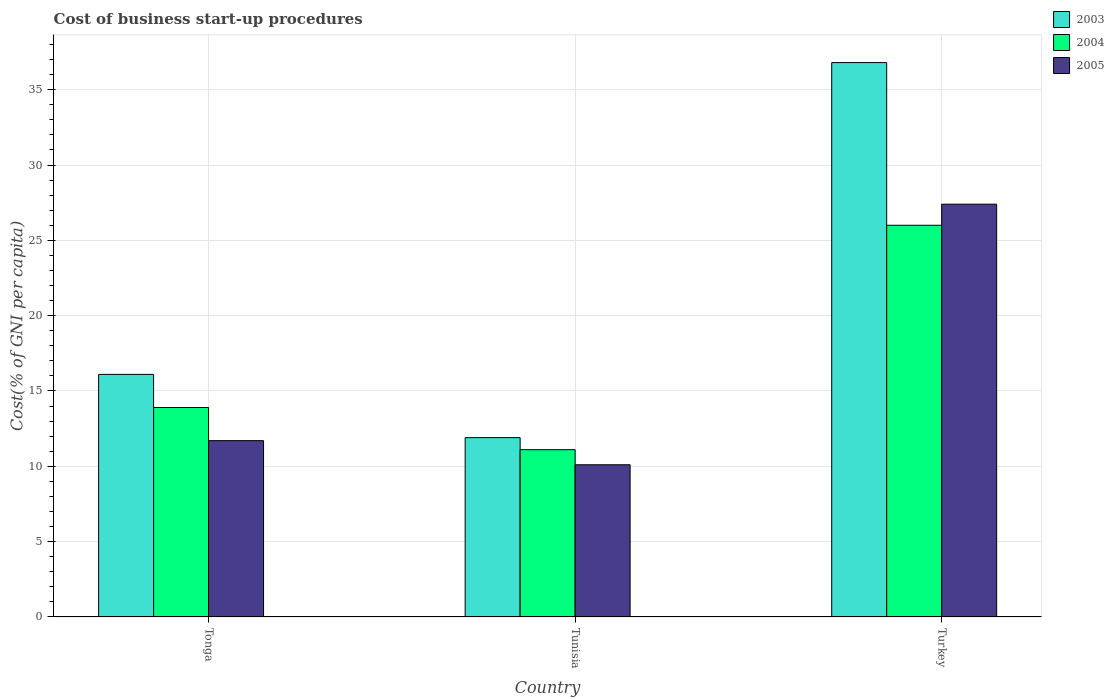Are the number of bars per tick equal to the number of legend labels?
Your response must be concise. Yes. How many bars are there on the 3rd tick from the left?
Keep it short and to the point. 3. What is the label of the 2nd group of bars from the left?
Keep it short and to the point. Tunisia. In how many cases, is the number of bars for a given country not equal to the number of legend labels?
Give a very brief answer. 0. What is the cost of business start-up procedures in 2005 in Tonga?
Provide a succinct answer. 11.7. Across all countries, what is the maximum cost of business start-up procedures in 2005?
Provide a succinct answer. 27.4. In which country was the cost of business start-up procedures in 2004 minimum?
Your answer should be very brief. Tunisia. What is the total cost of business start-up procedures in 2005 in the graph?
Give a very brief answer. 49.2. What is the difference between the cost of business start-up procedures in 2003 in Tonga and that in Turkey?
Offer a terse response. -20.7. What is the difference between the cost of business start-up procedures in 2003 in Turkey and the cost of business start-up procedures in 2004 in Tunisia?
Give a very brief answer. 25.7. What is the average cost of business start-up procedures in 2003 per country?
Your answer should be compact. 21.6. What is the difference between the cost of business start-up procedures of/in 2005 and cost of business start-up procedures of/in 2004 in Turkey?
Your response must be concise. 1.4. In how many countries, is the cost of business start-up procedures in 2003 greater than 5 %?
Offer a very short reply. 3. What is the ratio of the cost of business start-up procedures in 2003 in Tonga to that in Tunisia?
Your response must be concise. 1.35. What is the difference between the highest and the second highest cost of business start-up procedures in 2003?
Your response must be concise. 4.2. What is the difference between the highest and the lowest cost of business start-up procedures in 2003?
Provide a short and direct response. 24.9. Is the sum of the cost of business start-up procedures in 2005 in Tonga and Turkey greater than the maximum cost of business start-up procedures in 2004 across all countries?
Your answer should be very brief. Yes. What does the 2nd bar from the right in Tonga represents?
Ensure brevity in your answer.  2004. Are all the bars in the graph horizontal?
Keep it short and to the point. No. How many countries are there in the graph?
Your answer should be very brief. 3. What is the difference between two consecutive major ticks on the Y-axis?
Make the answer very short. 5. Does the graph contain any zero values?
Provide a short and direct response. No. Does the graph contain grids?
Offer a very short reply. Yes. How are the legend labels stacked?
Your answer should be compact. Vertical. What is the title of the graph?
Offer a very short reply. Cost of business start-up procedures. Does "1960" appear as one of the legend labels in the graph?
Provide a short and direct response. No. What is the label or title of the Y-axis?
Offer a very short reply. Cost(% of GNI per capita). What is the Cost(% of GNI per capita) in 2003 in Tonga?
Keep it short and to the point. 16.1. What is the Cost(% of GNI per capita) of 2004 in Tonga?
Offer a very short reply. 13.9. What is the Cost(% of GNI per capita) in 2003 in Tunisia?
Your answer should be very brief. 11.9. What is the Cost(% of GNI per capita) of 2005 in Tunisia?
Ensure brevity in your answer.  10.1. What is the Cost(% of GNI per capita) in 2003 in Turkey?
Make the answer very short. 36.8. What is the Cost(% of GNI per capita) of 2005 in Turkey?
Offer a terse response. 27.4. Across all countries, what is the maximum Cost(% of GNI per capita) of 2003?
Give a very brief answer. 36.8. Across all countries, what is the maximum Cost(% of GNI per capita) in 2004?
Keep it short and to the point. 26. Across all countries, what is the maximum Cost(% of GNI per capita) of 2005?
Your response must be concise. 27.4. Across all countries, what is the minimum Cost(% of GNI per capita) of 2003?
Give a very brief answer. 11.9. Across all countries, what is the minimum Cost(% of GNI per capita) of 2004?
Offer a very short reply. 11.1. What is the total Cost(% of GNI per capita) of 2003 in the graph?
Your response must be concise. 64.8. What is the total Cost(% of GNI per capita) in 2004 in the graph?
Give a very brief answer. 51. What is the total Cost(% of GNI per capita) of 2005 in the graph?
Give a very brief answer. 49.2. What is the difference between the Cost(% of GNI per capita) of 2003 in Tonga and that in Turkey?
Provide a short and direct response. -20.7. What is the difference between the Cost(% of GNI per capita) in 2005 in Tonga and that in Turkey?
Give a very brief answer. -15.7. What is the difference between the Cost(% of GNI per capita) in 2003 in Tunisia and that in Turkey?
Keep it short and to the point. -24.9. What is the difference between the Cost(% of GNI per capita) in 2004 in Tunisia and that in Turkey?
Your answer should be very brief. -14.9. What is the difference between the Cost(% of GNI per capita) of 2005 in Tunisia and that in Turkey?
Ensure brevity in your answer.  -17.3. What is the difference between the Cost(% of GNI per capita) of 2003 in Tonga and the Cost(% of GNI per capita) of 2004 in Tunisia?
Make the answer very short. 5. What is the difference between the Cost(% of GNI per capita) of 2004 in Tonga and the Cost(% of GNI per capita) of 2005 in Tunisia?
Give a very brief answer. 3.8. What is the difference between the Cost(% of GNI per capita) in 2004 in Tonga and the Cost(% of GNI per capita) in 2005 in Turkey?
Keep it short and to the point. -13.5. What is the difference between the Cost(% of GNI per capita) in 2003 in Tunisia and the Cost(% of GNI per capita) in 2004 in Turkey?
Offer a terse response. -14.1. What is the difference between the Cost(% of GNI per capita) of 2003 in Tunisia and the Cost(% of GNI per capita) of 2005 in Turkey?
Keep it short and to the point. -15.5. What is the difference between the Cost(% of GNI per capita) in 2004 in Tunisia and the Cost(% of GNI per capita) in 2005 in Turkey?
Your response must be concise. -16.3. What is the average Cost(% of GNI per capita) of 2003 per country?
Provide a succinct answer. 21.6. What is the average Cost(% of GNI per capita) in 2004 per country?
Ensure brevity in your answer.  17. What is the difference between the Cost(% of GNI per capita) of 2003 and Cost(% of GNI per capita) of 2004 in Tonga?
Offer a terse response. 2.2. What is the difference between the Cost(% of GNI per capita) in 2004 and Cost(% of GNI per capita) in 2005 in Tonga?
Make the answer very short. 2.2. What is the difference between the Cost(% of GNI per capita) of 2003 and Cost(% of GNI per capita) of 2004 in Tunisia?
Your answer should be compact. 0.8. What is the difference between the Cost(% of GNI per capita) of 2004 and Cost(% of GNI per capita) of 2005 in Tunisia?
Your answer should be compact. 1. What is the difference between the Cost(% of GNI per capita) of 2003 and Cost(% of GNI per capita) of 2004 in Turkey?
Offer a very short reply. 10.8. What is the ratio of the Cost(% of GNI per capita) of 2003 in Tonga to that in Tunisia?
Provide a succinct answer. 1.35. What is the ratio of the Cost(% of GNI per capita) of 2004 in Tonga to that in Tunisia?
Give a very brief answer. 1.25. What is the ratio of the Cost(% of GNI per capita) of 2005 in Tonga to that in Tunisia?
Give a very brief answer. 1.16. What is the ratio of the Cost(% of GNI per capita) of 2003 in Tonga to that in Turkey?
Ensure brevity in your answer.  0.44. What is the ratio of the Cost(% of GNI per capita) in 2004 in Tonga to that in Turkey?
Ensure brevity in your answer.  0.53. What is the ratio of the Cost(% of GNI per capita) of 2005 in Tonga to that in Turkey?
Provide a short and direct response. 0.43. What is the ratio of the Cost(% of GNI per capita) of 2003 in Tunisia to that in Turkey?
Give a very brief answer. 0.32. What is the ratio of the Cost(% of GNI per capita) in 2004 in Tunisia to that in Turkey?
Ensure brevity in your answer.  0.43. What is the ratio of the Cost(% of GNI per capita) of 2005 in Tunisia to that in Turkey?
Keep it short and to the point. 0.37. What is the difference between the highest and the second highest Cost(% of GNI per capita) of 2003?
Provide a succinct answer. 20.7. What is the difference between the highest and the lowest Cost(% of GNI per capita) in 2003?
Provide a succinct answer. 24.9. What is the difference between the highest and the lowest Cost(% of GNI per capita) in 2004?
Make the answer very short. 14.9. What is the difference between the highest and the lowest Cost(% of GNI per capita) of 2005?
Provide a succinct answer. 17.3. 